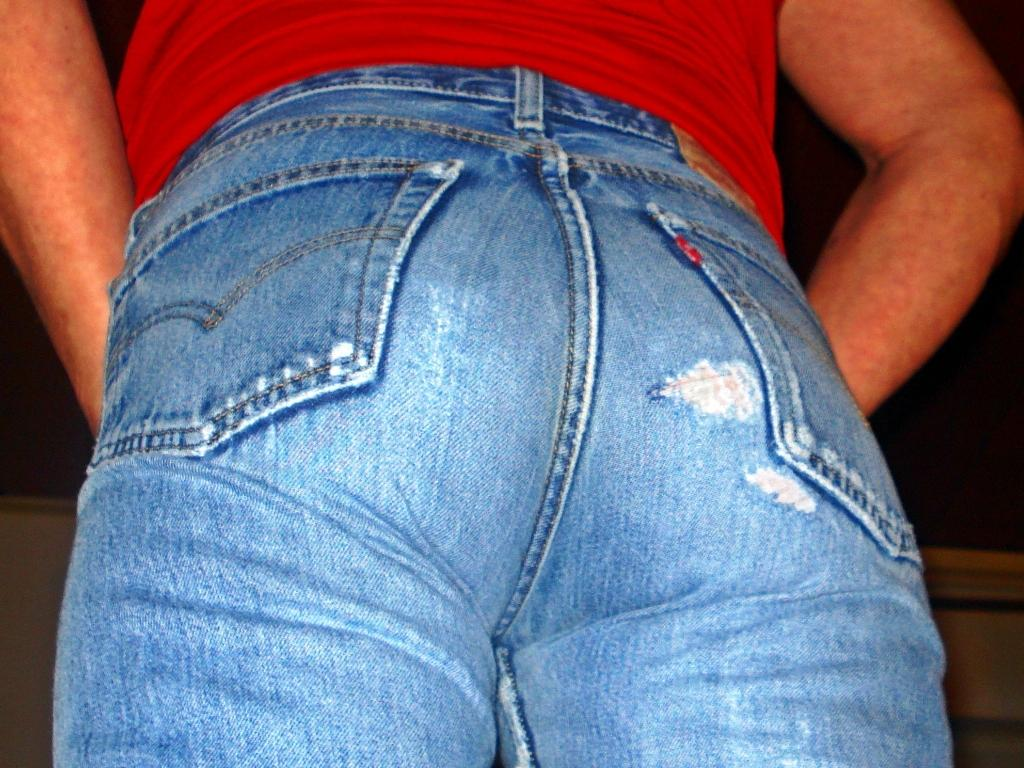What type of living organism can be seen in the image? There is a human in the image. What can be observed about the background of the image? The background of the image is dark. What type of sock is the human wearing in the image? There is no information about a sock in the image, so it cannot be determined what type of sock the human might be wearing. 